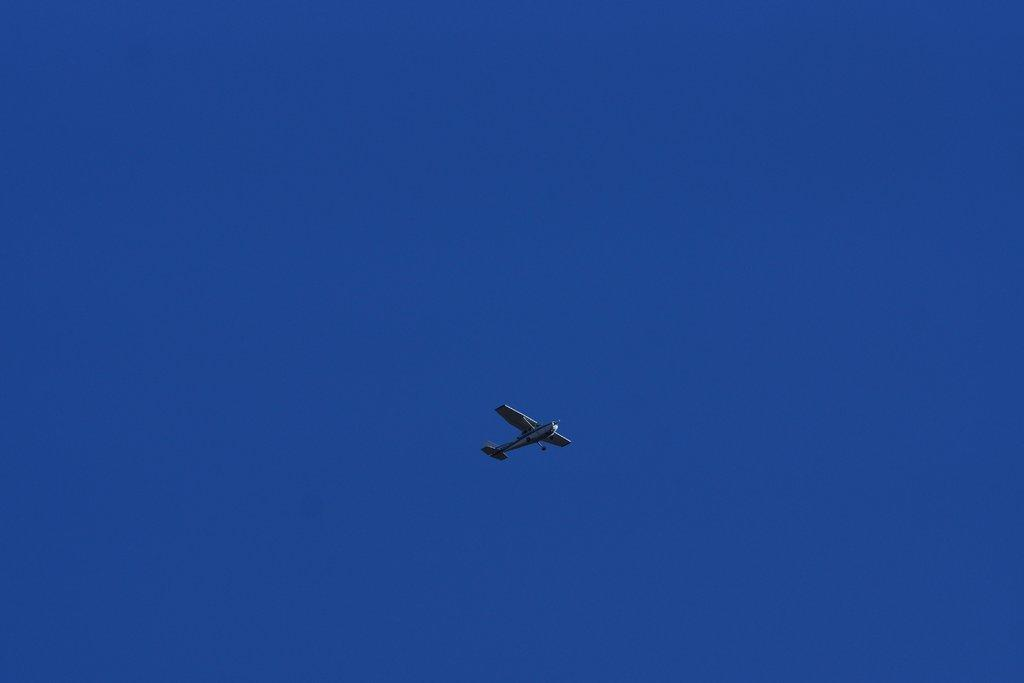What is the main subject of the image? The main subject of the image is an aircraft. Can you describe the position of the aircraft in the image? The aircraft is in the air in the image. What color is the sky in the image? The sky is blue in the image. Can you see a snail crawling on the aircraft in the image? There is no snail present on the aircraft in the image. How many toes are visible on the aircraft in the image? Aircrafts do not have toes, so none are visible in the image. 